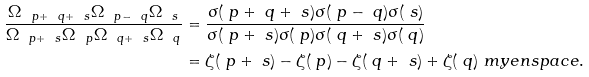<formula> <loc_0><loc_0><loc_500><loc_500>\frac { \Omega _ { \ p + \ q + \ s } \Omega _ { \ p - \ q } \Omega _ { \ s } } { \Omega _ { \ p + \ s } \Omega _ { \ p } \Omega _ { \ q + \ s } \Omega _ { \ q } } & = \frac { \sigma ( \ p + \ q + \ s ) \sigma ( \ p - \ q ) \sigma ( \ s ) } { \sigma ( \ p + \ s ) \sigma ( \ p ) \sigma ( \ q + \ s ) \sigma ( \ q ) } \\ & = \zeta ( \ p + \ s ) - \zeta ( \ p ) - \zeta ( \ q + \ s ) + \zeta ( \ q ) \ m y e n s p a c e .</formula> 